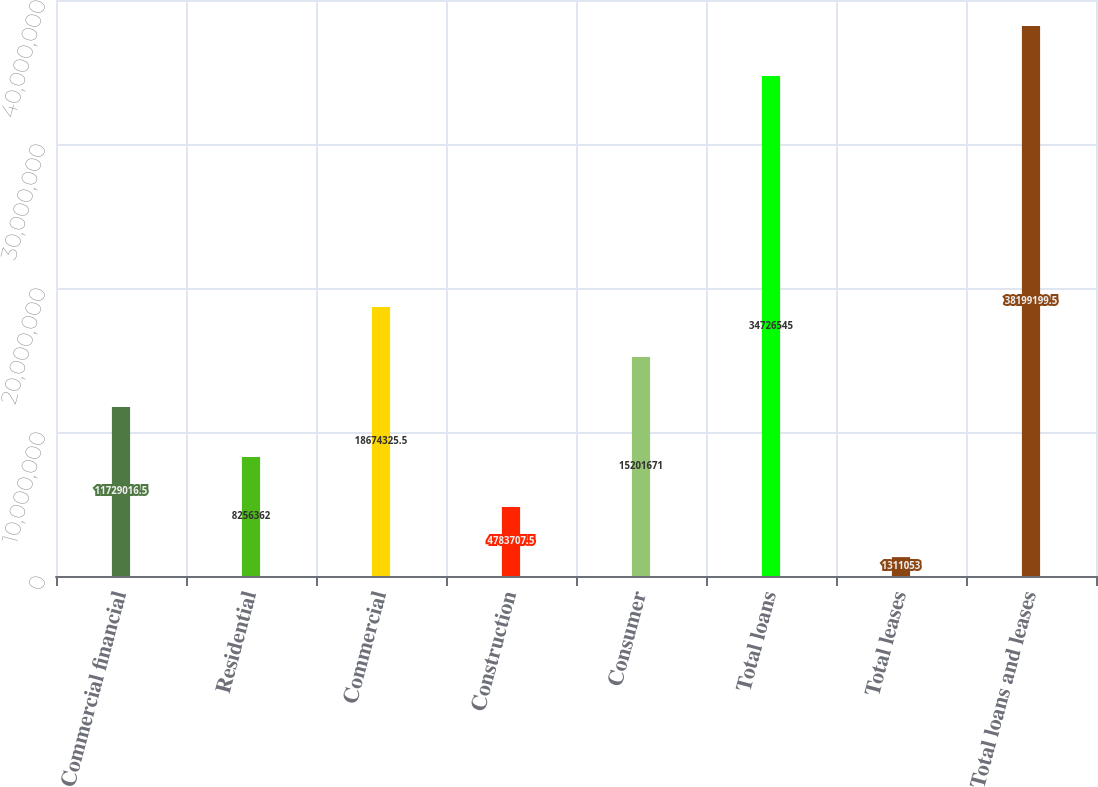<chart> <loc_0><loc_0><loc_500><loc_500><bar_chart><fcel>Commercial financial<fcel>Residential<fcel>Commercial<fcel>Construction<fcel>Consumer<fcel>Total loans<fcel>Total leases<fcel>Total loans and leases<nl><fcel>1.1729e+07<fcel>8.25636e+06<fcel>1.86743e+07<fcel>4.78371e+06<fcel>1.52017e+07<fcel>3.47265e+07<fcel>1.31105e+06<fcel>3.81992e+07<nl></chart> 